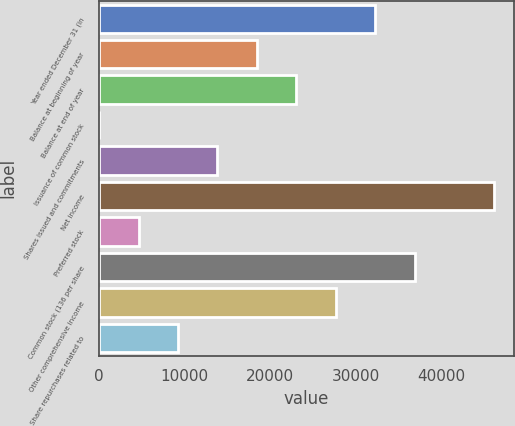Convert chart to OTSL. <chart><loc_0><loc_0><loc_500><loc_500><bar_chart><fcel>Year ended December 31 (in<fcel>Balance at beginning of year<fcel>Balance at end of year<fcel>Issuance of common stock<fcel>Shares issued and commitments<fcel>Net income<fcel>Preferred stock<fcel>Common stock (136 per share<fcel>Other comprehensive income<fcel>Share repurchases related to<nl><fcel>32313.8<fcel>18473.6<fcel>23087<fcel>20<fcel>13860.2<fcel>46154<fcel>4633.4<fcel>36927.2<fcel>27700.4<fcel>9246.8<nl></chart> 